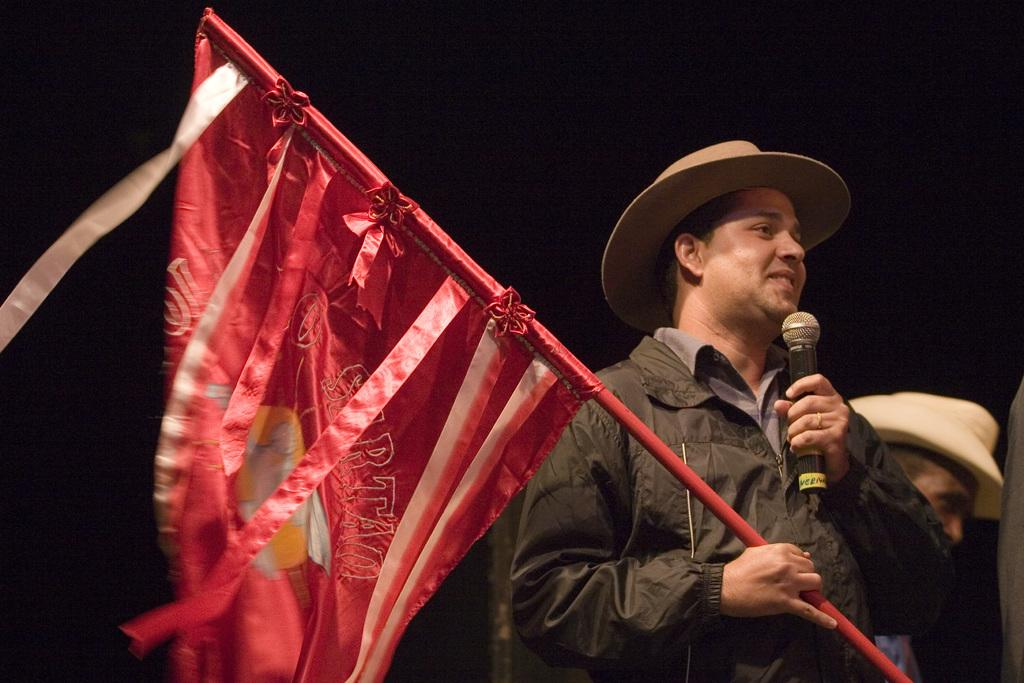How many people are in the image? There are two persons in the image. What are the persons wearing? Both persons are wearing hats. What are the persons holding? One person is holding a flag, and the other person is holding a mic. What is the color of the background in the image? The background of the image is dark. What type of worm can be seen crawling out of the person's pocket in the image? There is no worm present in the image, nor is there any mention of a pocket. 